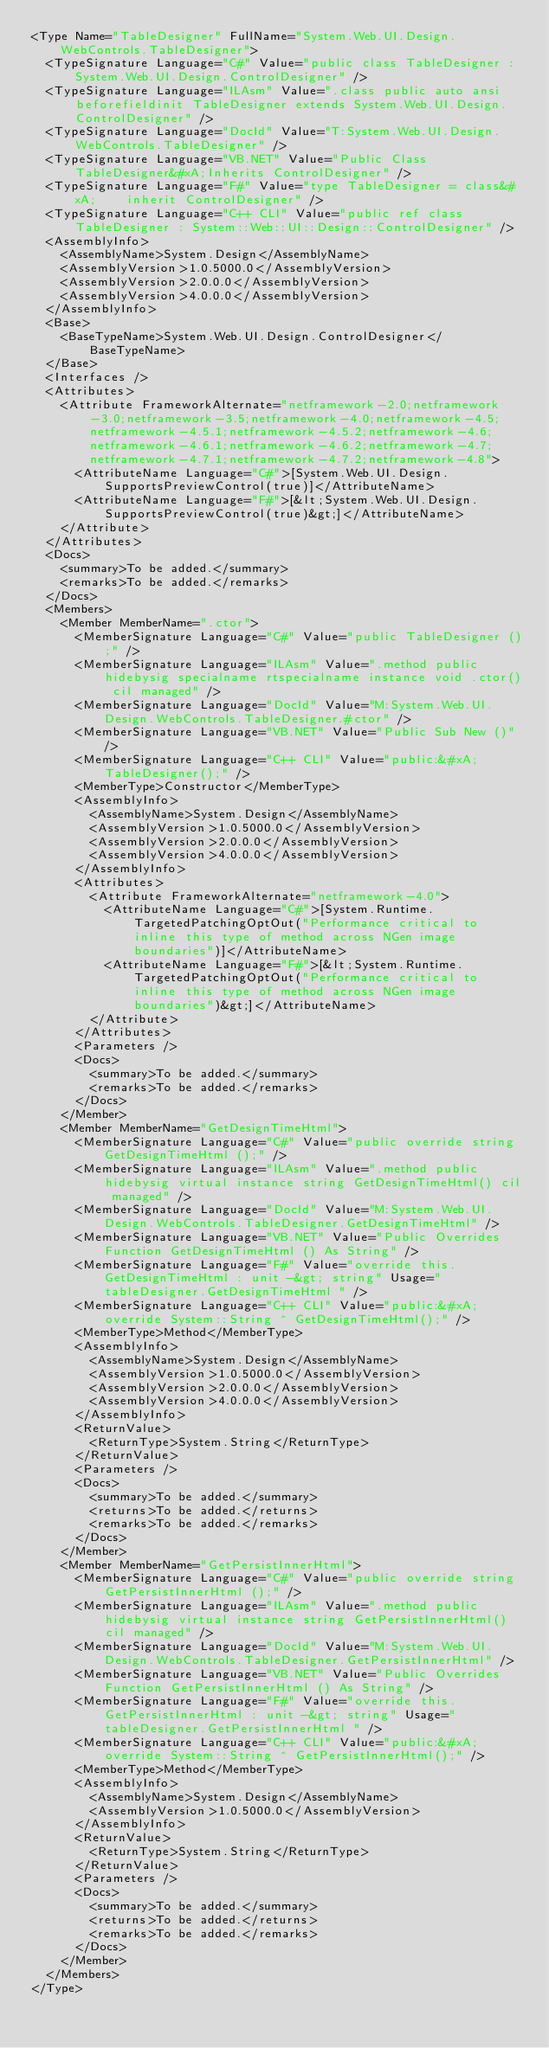Convert code to text. <code><loc_0><loc_0><loc_500><loc_500><_XML_><Type Name="TableDesigner" FullName="System.Web.UI.Design.WebControls.TableDesigner">
  <TypeSignature Language="C#" Value="public class TableDesigner : System.Web.UI.Design.ControlDesigner" />
  <TypeSignature Language="ILAsm" Value=".class public auto ansi beforefieldinit TableDesigner extends System.Web.UI.Design.ControlDesigner" />
  <TypeSignature Language="DocId" Value="T:System.Web.UI.Design.WebControls.TableDesigner" />
  <TypeSignature Language="VB.NET" Value="Public Class TableDesigner&#xA;Inherits ControlDesigner" />
  <TypeSignature Language="F#" Value="type TableDesigner = class&#xA;    inherit ControlDesigner" />
  <TypeSignature Language="C++ CLI" Value="public ref class TableDesigner : System::Web::UI::Design::ControlDesigner" />
  <AssemblyInfo>
    <AssemblyName>System.Design</AssemblyName>
    <AssemblyVersion>1.0.5000.0</AssemblyVersion>
    <AssemblyVersion>2.0.0.0</AssemblyVersion>
    <AssemblyVersion>4.0.0.0</AssemblyVersion>
  </AssemblyInfo>
  <Base>
    <BaseTypeName>System.Web.UI.Design.ControlDesigner</BaseTypeName>
  </Base>
  <Interfaces />
  <Attributes>
    <Attribute FrameworkAlternate="netframework-2.0;netframework-3.0;netframework-3.5;netframework-4.0;netframework-4.5;netframework-4.5.1;netframework-4.5.2;netframework-4.6;netframework-4.6.1;netframework-4.6.2;netframework-4.7;netframework-4.7.1;netframework-4.7.2;netframework-4.8">
      <AttributeName Language="C#">[System.Web.UI.Design.SupportsPreviewControl(true)]</AttributeName>
      <AttributeName Language="F#">[&lt;System.Web.UI.Design.SupportsPreviewControl(true)&gt;]</AttributeName>
    </Attribute>
  </Attributes>
  <Docs>
    <summary>To be added.</summary>
    <remarks>To be added.</remarks>
  </Docs>
  <Members>
    <Member MemberName=".ctor">
      <MemberSignature Language="C#" Value="public TableDesigner ();" />
      <MemberSignature Language="ILAsm" Value=".method public hidebysig specialname rtspecialname instance void .ctor() cil managed" />
      <MemberSignature Language="DocId" Value="M:System.Web.UI.Design.WebControls.TableDesigner.#ctor" />
      <MemberSignature Language="VB.NET" Value="Public Sub New ()" />
      <MemberSignature Language="C++ CLI" Value="public:&#xA; TableDesigner();" />
      <MemberType>Constructor</MemberType>
      <AssemblyInfo>
        <AssemblyName>System.Design</AssemblyName>
        <AssemblyVersion>1.0.5000.0</AssemblyVersion>
        <AssemblyVersion>2.0.0.0</AssemblyVersion>
        <AssemblyVersion>4.0.0.0</AssemblyVersion>
      </AssemblyInfo>
      <Attributes>
        <Attribute FrameworkAlternate="netframework-4.0">
          <AttributeName Language="C#">[System.Runtime.TargetedPatchingOptOut("Performance critical to inline this type of method across NGen image boundaries")]</AttributeName>
          <AttributeName Language="F#">[&lt;System.Runtime.TargetedPatchingOptOut("Performance critical to inline this type of method across NGen image boundaries")&gt;]</AttributeName>
        </Attribute>
      </Attributes>
      <Parameters />
      <Docs>
        <summary>To be added.</summary>
        <remarks>To be added.</remarks>
      </Docs>
    </Member>
    <Member MemberName="GetDesignTimeHtml">
      <MemberSignature Language="C#" Value="public override string GetDesignTimeHtml ();" />
      <MemberSignature Language="ILAsm" Value=".method public hidebysig virtual instance string GetDesignTimeHtml() cil managed" />
      <MemberSignature Language="DocId" Value="M:System.Web.UI.Design.WebControls.TableDesigner.GetDesignTimeHtml" />
      <MemberSignature Language="VB.NET" Value="Public Overrides Function GetDesignTimeHtml () As String" />
      <MemberSignature Language="F#" Value="override this.GetDesignTimeHtml : unit -&gt; string" Usage="tableDesigner.GetDesignTimeHtml " />
      <MemberSignature Language="C++ CLI" Value="public:&#xA; override System::String ^ GetDesignTimeHtml();" />
      <MemberType>Method</MemberType>
      <AssemblyInfo>
        <AssemblyName>System.Design</AssemblyName>
        <AssemblyVersion>1.0.5000.0</AssemblyVersion>
        <AssemblyVersion>2.0.0.0</AssemblyVersion>
        <AssemblyVersion>4.0.0.0</AssemblyVersion>
      </AssemblyInfo>
      <ReturnValue>
        <ReturnType>System.String</ReturnType>
      </ReturnValue>
      <Parameters />
      <Docs>
        <summary>To be added.</summary>
        <returns>To be added.</returns>
        <remarks>To be added.</remarks>
      </Docs>
    </Member>
    <Member MemberName="GetPersistInnerHtml">
      <MemberSignature Language="C#" Value="public override string GetPersistInnerHtml ();" />
      <MemberSignature Language="ILAsm" Value=".method public hidebysig virtual instance string GetPersistInnerHtml() cil managed" />
      <MemberSignature Language="DocId" Value="M:System.Web.UI.Design.WebControls.TableDesigner.GetPersistInnerHtml" />
      <MemberSignature Language="VB.NET" Value="Public Overrides Function GetPersistInnerHtml () As String" />
      <MemberSignature Language="F#" Value="override this.GetPersistInnerHtml : unit -&gt; string" Usage="tableDesigner.GetPersistInnerHtml " />
      <MemberSignature Language="C++ CLI" Value="public:&#xA; override System::String ^ GetPersistInnerHtml();" />
      <MemberType>Method</MemberType>
      <AssemblyInfo>
        <AssemblyName>System.Design</AssemblyName>
        <AssemblyVersion>1.0.5000.0</AssemblyVersion>
      </AssemblyInfo>
      <ReturnValue>
        <ReturnType>System.String</ReturnType>
      </ReturnValue>
      <Parameters />
      <Docs>
        <summary>To be added.</summary>
        <returns>To be added.</returns>
        <remarks>To be added.</remarks>
      </Docs>
    </Member>
  </Members>
</Type>
</code> 